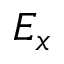<formula> <loc_0><loc_0><loc_500><loc_500>E _ { x }</formula> 